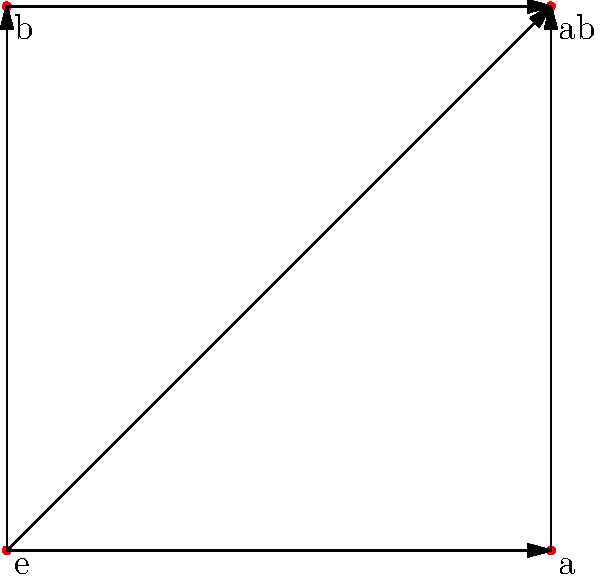In the context of improving the user interface for visualizing group structures, consider the graph representation of Klein's four-group shown above. How many distinct cycles of length 3 (triangles) are present in this graph, and what does this reveal about the group's structure? To answer this question, we'll follow these steps:

1. Understand the graph representation:
   - Nodes represent group elements: e (identity), a, b, and ab
   - Edges represent relationships between elements

2. Recall the definition of a cycle:
   - A cycle is a path that starts and ends at the same node
   - A cycle of length 3 forms a triangle in the graph

3. Identify all possible triangles in the graph:
   - Triangle 1: e → a → ab → e
   - Triangle 2: e → b → ab → e
   - Triangle 3: a → ab → b → a
   - Triangle 4: e → a → b → e

4. Count the number of distinct triangles:
   There are 4 distinct triangles in the graph.

5. Interpret the result:
   - The presence of multiple cycles indicates that the group has a high degree of symmetry
   - Each cycle represents a different way to combine elements and return to the identity
   - The four triangles correspond to the four subgroups of order 2 in Klein's four-group

6. Relate to UI/UX design:
   - Visualizing group structures as graphs can help users understand complex relationships
   - The symmetry revealed by the cycles can be emphasized in the interface design
   - This representation allows for intuitive exploration of group properties
Answer: 4 triangles, revealing high symmetry and subgroup structure 